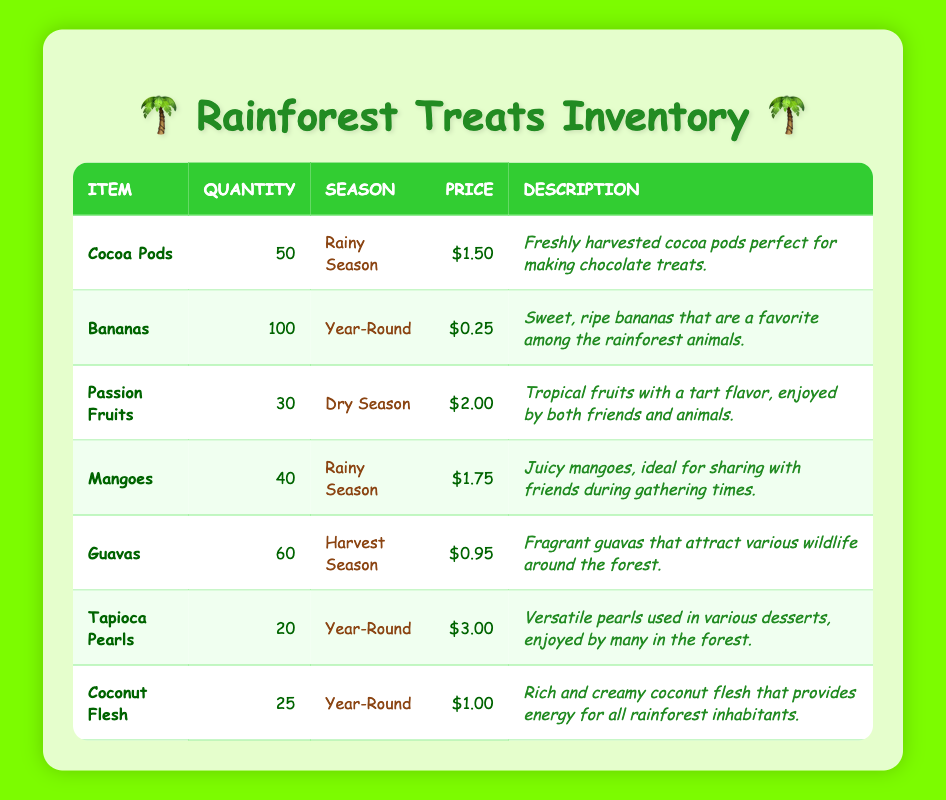What is the total quantity of Bananas in stock? The total quantity of Bananas listed in the table is 100. This value is found directly in the quantity column for the Bananas row.
Answer: 100 Which item has the highest unit price? By examining the unit price column, the highest price is $3.00 for Tapioca Pearls. It is the only item priced at this amount compared to others listed.
Answer: Tapioca Pearls Are Guavas available during the Rainy Season? According to the season column, Guavas are available in the Harvest Season, which means they are not available during the Rainy Season.
Answer: No What is the average unit price of all items in the inventory? To find the average unit price, first sum the unit prices: 1.5 + 0.25 + 2.0 + 1.75 + 0.95 + 3.0 + 1.0 = 10.45. Then, divide by the number of items (7): 10.45 / 7 = approximately 1.49.
Answer: 1.49 How many items are available year-round? Looking at the season column, there are three items that are available year-round: Bananas, Tapioca Pearls, and Coconut Flesh. Their names can be found in the item name column against "Year-round".
Answer: 3 What is the total quantity of fruit available during the Rainy Season? The Rainy Season has two fruit items: Cocoa Pods (50) and Mangoes (40). To find the total, we add these quantities together: 50 + 40 = 90.
Answer: 90 Is the price of Passion Fruits higher or lower than that of Mangoes? The price of Passion Fruits is $2.00, and the price of Mangoes is $1.75. Since $2.00 is greater than $1.75, Passion Fruits are higher in price compared to Mangoes.
Answer: Higher What is the total quantity of items available in the inventory? To find the total quantity, we sum all items listed: 50 + 100 + 30 + 40 + 60 + 20 + 25 = 325. This sum includes every item's quantity listed in the quantity column.
Answer: 325 Which fruit has a price of less than $1.00? The table shows that Guavas at $0.95 and Coconut Flesh at $1.00 are related to this question. Only Guavas have a price that is less than $1.00, while Coconut Flesh is exactly at that price.
Answer: Guavas 